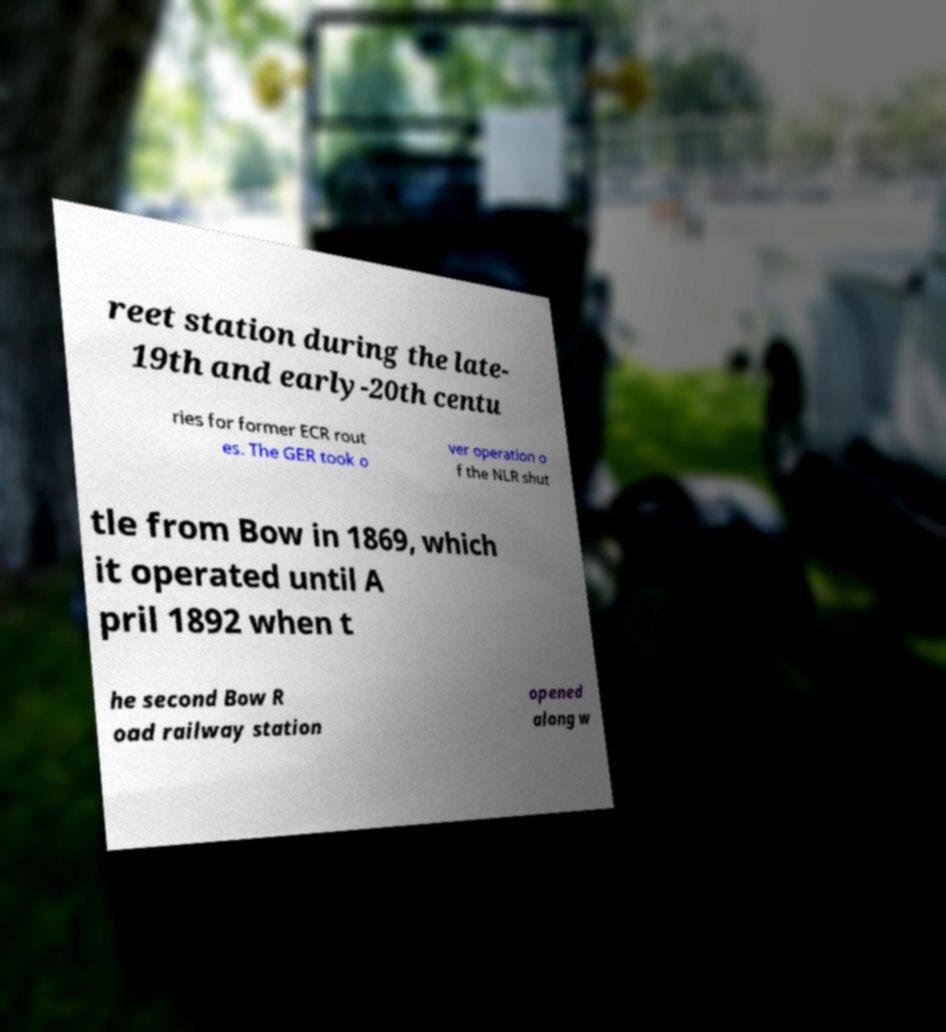Please identify and transcribe the text found in this image. reet station during the late- 19th and early-20th centu ries for former ECR rout es. The GER took o ver operation o f the NLR shut tle from Bow in 1869, which it operated until A pril 1892 when t he second Bow R oad railway station opened along w 